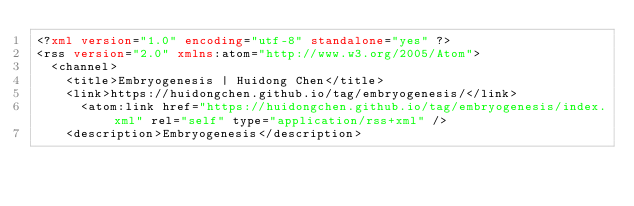<code> <loc_0><loc_0><loc_500><loc_500><_XML_><?xml version="1.0" encoding="utf-8" standalone="yes" ?>
<rss version="2.0" xmlns:atom="http://www.w3.org/2005/Atom">
  <channel>
    <title>Embryogenesis | Huidong Chen</title>
    <link>https://huidongchen.github.io/tag/embryogenesis/</link>
      <atom:link href="https://huidongchen.github.io/tag/embryogenesis/index.xml" rel="self" type="application/rss+xml" />
    <description>Embryogenesis</description></code> 